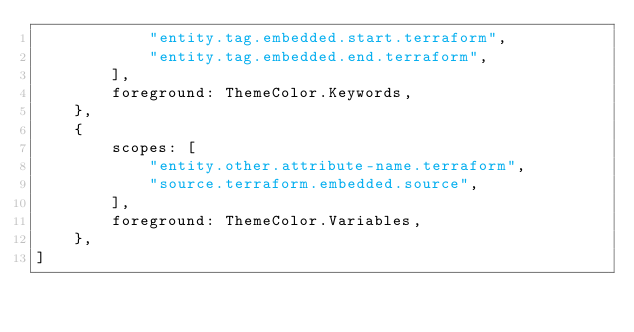Convert code to text. <code><loc_0><loc_0><loc_500><loc_500><_TypeScript_>            "entity.tag.embedded.start.terraform",
            "entity.tag.embedded.end.terraform",
        ],
        foreground: ThemeColor.Keywords,
    },
    {
        scopes: [
            "entity.other.attribute-name.terraform",
            "source.terraform.embedded.source",
        ],
        foreground: ThemeColor.Variables,
    },
]
</code> 